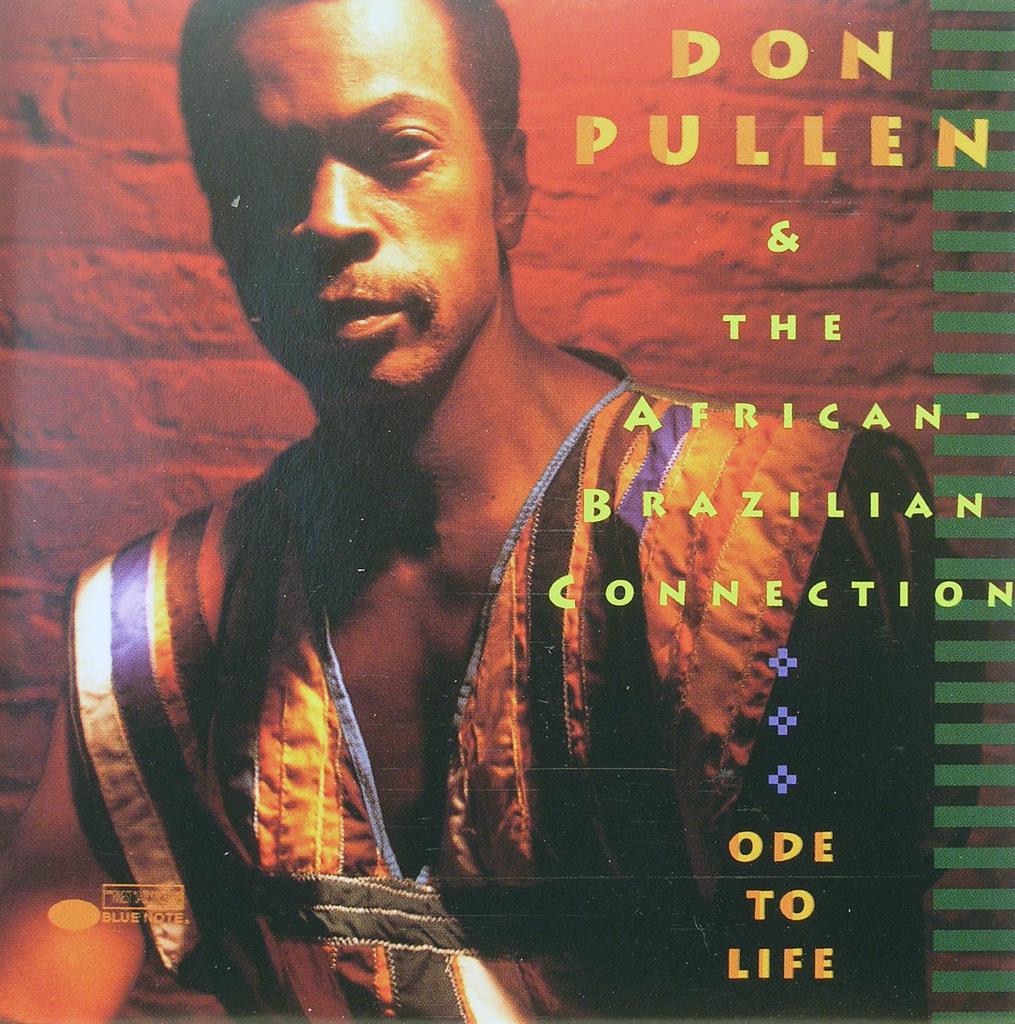Who is the young man?
Provide a short and direct response. Don pullen. What is the album title?
Give a very brief answer. Ode to life. 